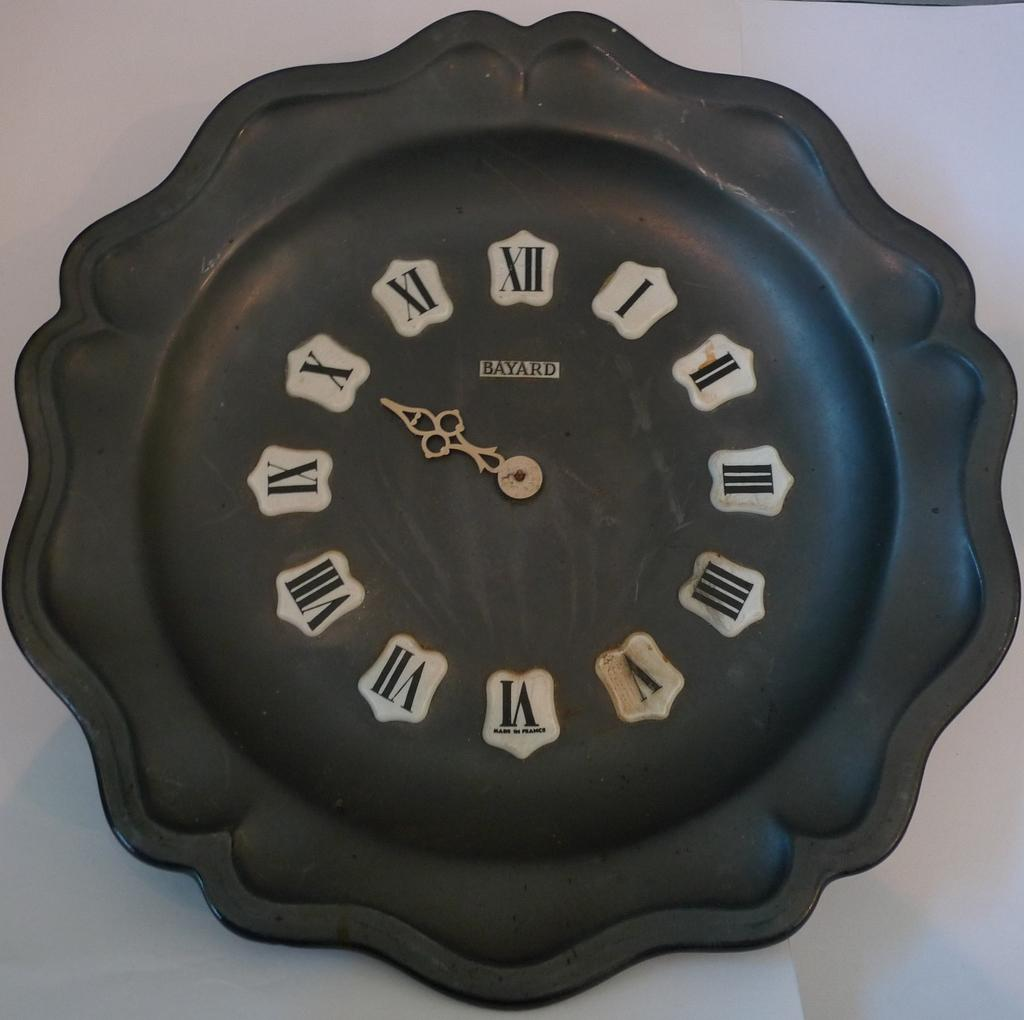<image>
Offer a succinct explanation of the picture presented. a clock with the word Bayard at the top 